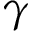<formula> <loc_0><loc_0><loc_500><loc_500>\gamma</formula> 